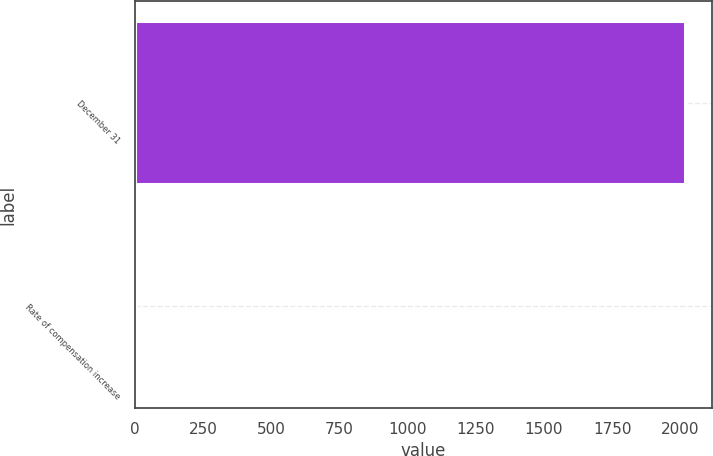<chart> <loc_0><loc_0><loc_500><loc_500><bar_chart><fcel>December 31<fcel>Rate of compensation increase<nl><fcel>2016<fcel>3.5<nl></chart> 